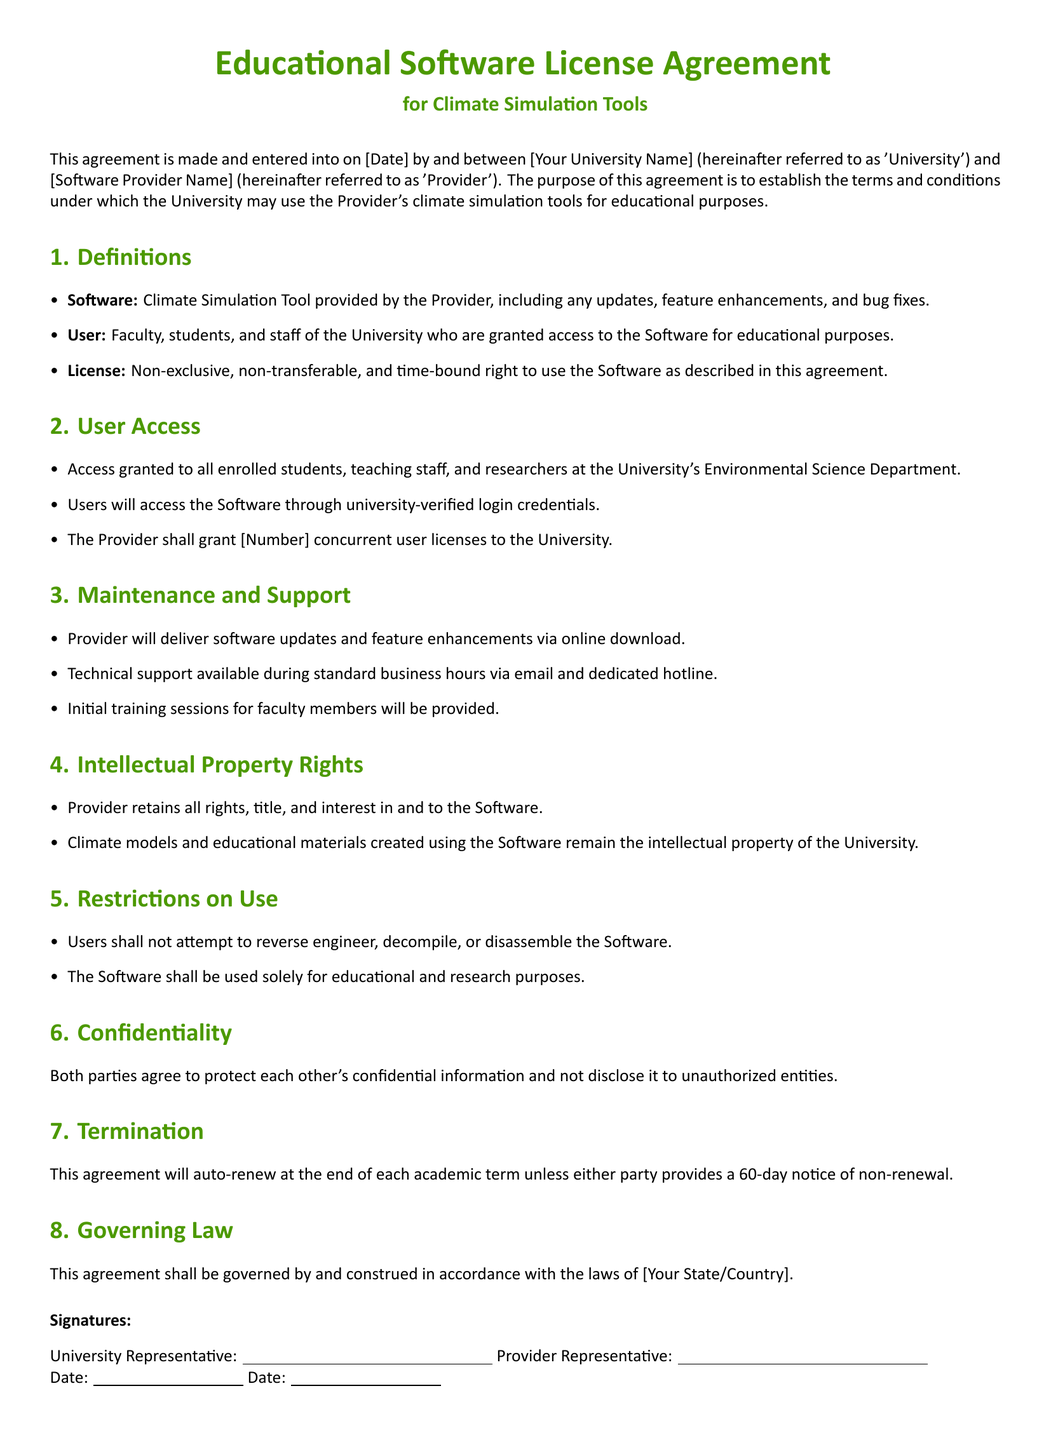What is the date of the agreement? The date of the agreement is specified as [Date] in the document.
Answer: [Date] How many concurrent user licenses are granted? The number of concurrent user licenses is indicated as [Number] in the document.
Answer: [Number] Who are the users allowed access to the software? Users allowed access are defined as faculty, students, and staff of the University.
Answer: faculty, students, and staff What type of support is provided during standard business hours? Technical support is mentioned as being available via email and a dedicated hotline.
Answer: email and hotline What happens if either party wants to terminate the agreement? The document states that a 60-day notice of non-renewal must be provided.
Answer: 60-day notice What rights does the Provider retain? The Provider retains all rights, title, and interest in and to the Software.
Answer: all rights, title, and interest For what purposes is the Software allowed to be used? The Software is permitted to be used solely for educational and research purposes.
Answer: educational and research purposes What is provided for faculty members as part of maintenance? Initial training sessions for faculty members are specified as part of the maintenance.
Answer: Initial training sessions 